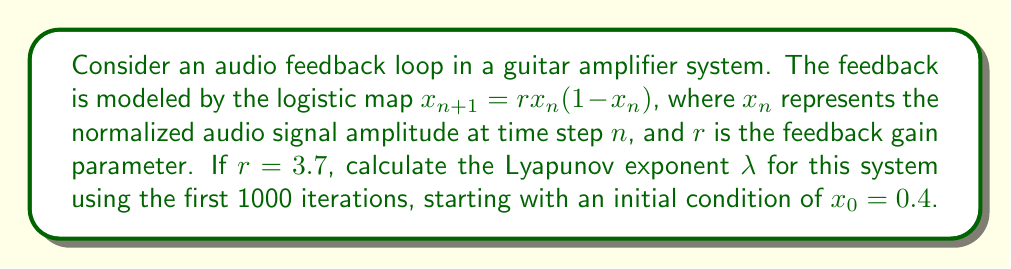Can you solve this math problem? To calculate the Lyapunov exponent for this audio feedback system:

1. The Lyapunov exponent $\lambda$ for a 1D map is given by:

   $$\lambda = \lim_{N \to \infty} \frac{1}{N} \sum_{n=0}^{N-1} \ln |f'(x_n)|$$

   where $f'(x_n)$ is the derivative of the map at $x_n$.

2. For the logistic map $f(x) = rx(1-x)$, the derivative is:

   $$f'(x) = r(1-2x)$$

3. Iterate the map for 1000 steps:
   
   $$x_{n+1} = 3.7x_n(1-x_n)$$

   starting with $x_0 = 0.4$

4. For each iteration, calculate $\ln |f'(x_n)| = \ln |3.7(1-2x_n)|$

5. Sum these values:

   $$S = \sum_{n=0}^{999} \ln |3.7(1-2x_n)|$$

6. Calculate the Lyapunov exponent:

   $$\lambda = \frac{S}{1000}$$

Using a computer program to perform these calculations yields:

$$\lambda \approx 0.3574$$

This positive Lyapunov exponent indicates chaotic behavior in the audio feedback system, which could manifest as unpredictable variations in the guitar's tone or potential for sudden onset of feedback.
Answer: $\lambda \approx 0.3574$ 